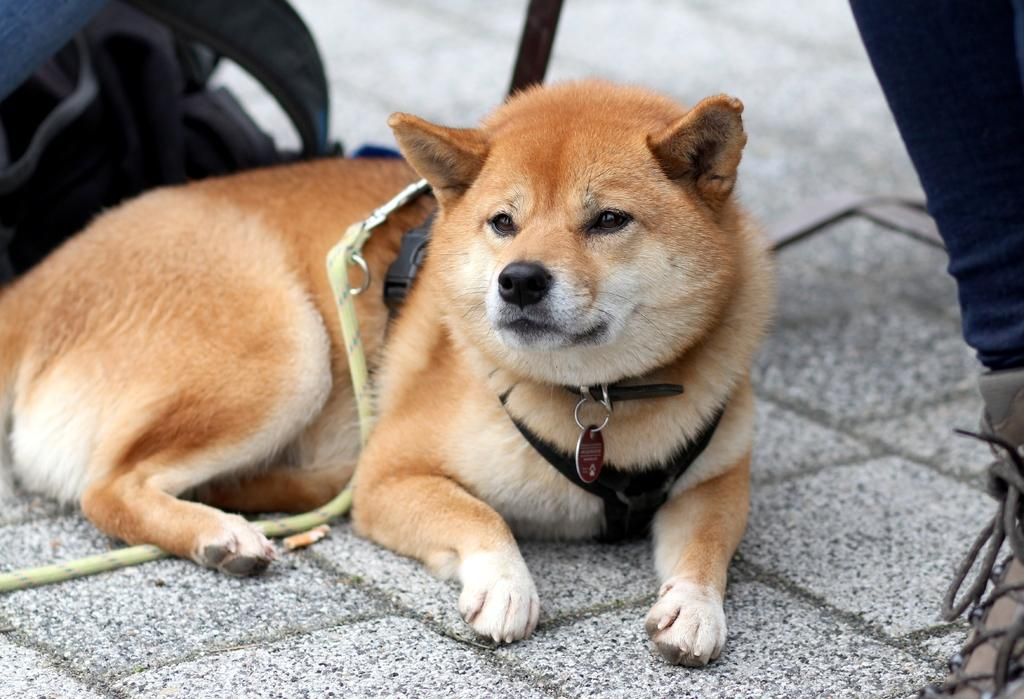What animal can be seen in the image? There is a dog in the image. What is the dog doing in the image? The dog is sitting on the ground. How is the dog being held in the image? There is a person holding the dog with a belt. What is the color of the dog in the image? The dog is brown in color. What type of jewel can be seen around the dog's neck in the image? There is no jewel visible around the dog's neck in the image. What is the weather like in the image? The provided facts do not mention the weather, so we cannot determine the weather from the image. 